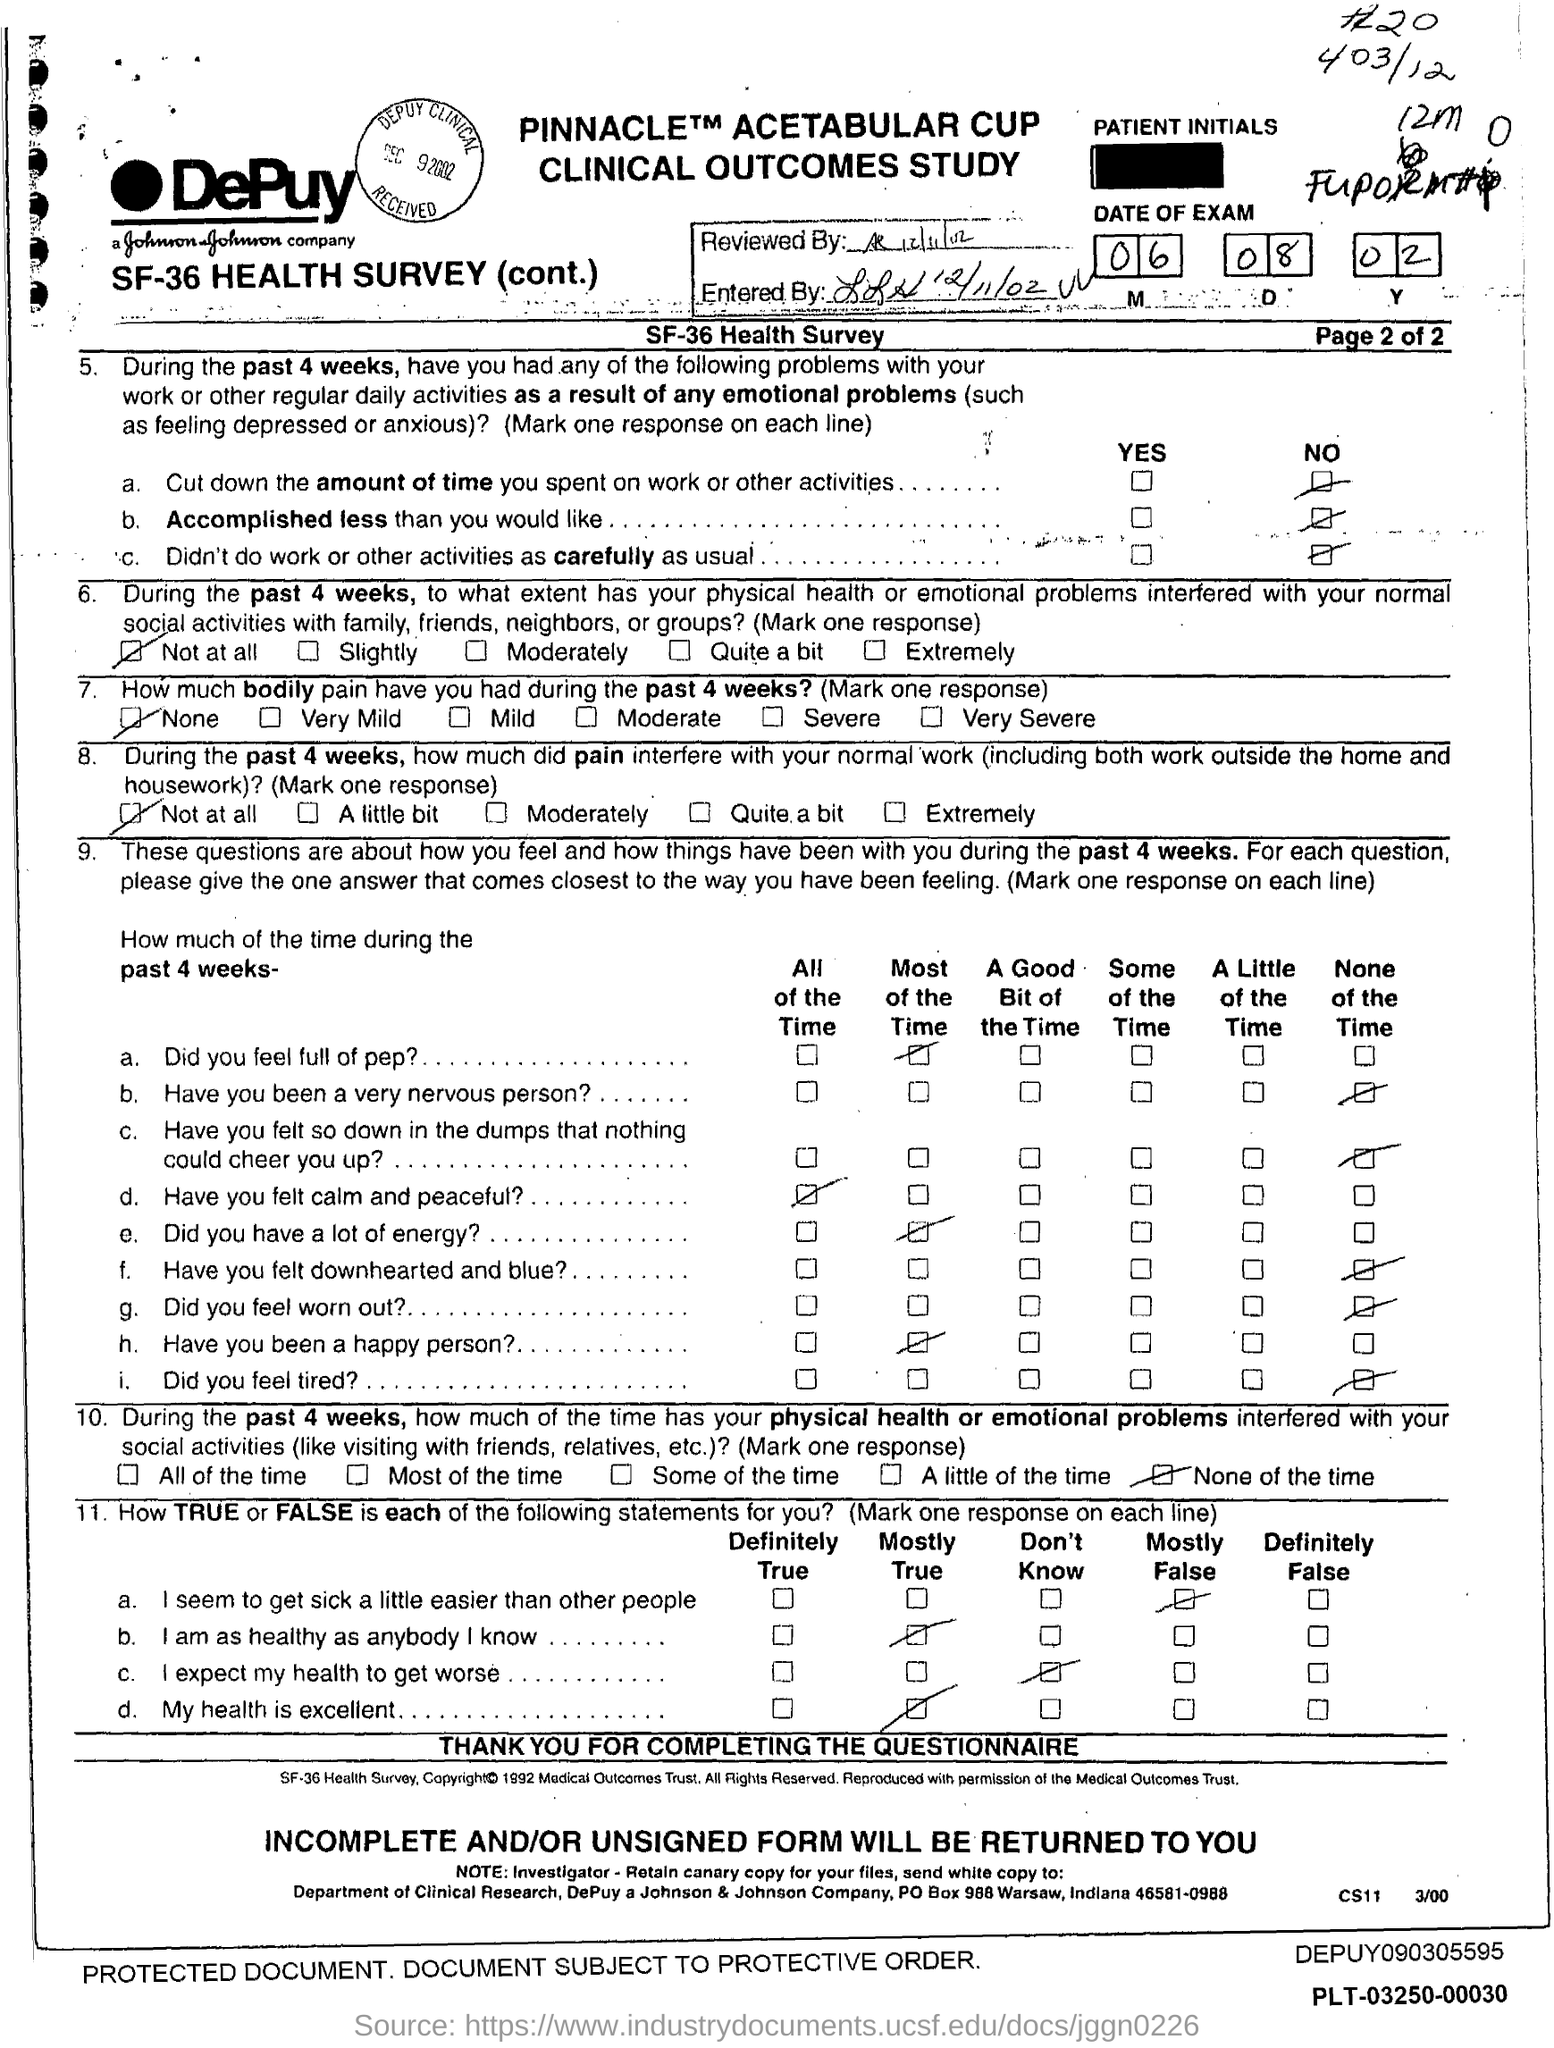What is the Entered date mentioned in the document?
Your answer should be compact. 12/11/02. What is the Reviewed date mentioned in the document?
Make the answer very short. 12/11/02. 